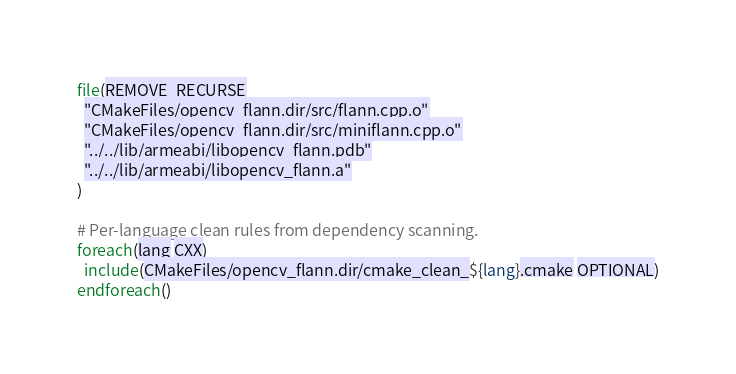Convert code to text. <code><loc_0><loc_0><loc_500><loc_500><_CMake_>file(REMOVE_RECURSE
  "CMakeFiles/opencv_flann.dir/src/flann.cpp.o"
  "CMakeFiles/opencv_flann.dir/src/miniflann.cpp.o"
  "../../lib/armeabi/libopencv_flann.pdb"
  "../../lib/armeabi/libopencv_flann.a"
)

# Per-language clean rules from dependency scanning.
foreach(lang CXX)
  include(CMakeFiles/opencv_flann.dir/cmake_clean_${lang}.cmake OPTIONAL)
endforeach()
</code> 